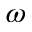<formula> <loc_0><loc_0><loc_500><loc_500>\omega</formula> 